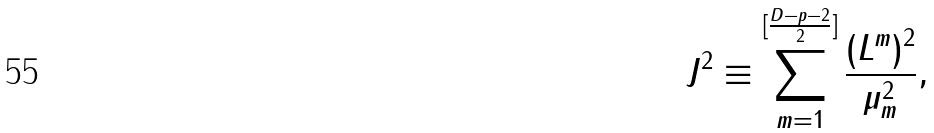<formula> <loc_0><loc_0><loc_500><loc_500>J ^ { 2 } \equiv \sum _ { m = 1 } ^ { [ \frac { D - p - 2 } { 2 } ] } \frac { ( L ^ { m } ) ^ { 2 } } { \mu _ { m } ^ { 2 } } ,</formula> 